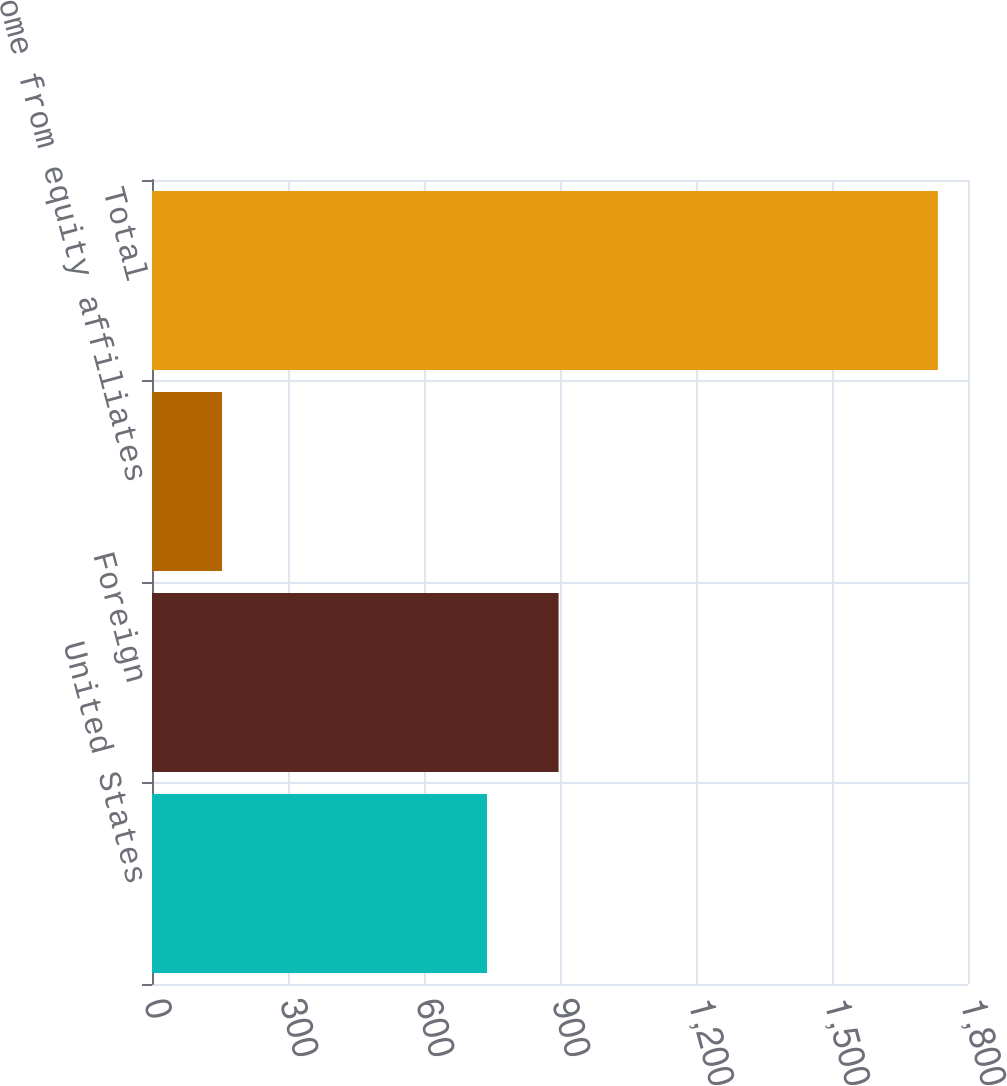Convert chart to OTSL. <chart><loc_0><loc_0><loc_500><loc_500><bar_chart><fcel>United States<fcel>Foreign<fcel>Income from equity affiliates<fcel>Total<nl><fcel>739<fcel>896.9<fcel>154.5<fcel>1733.5<nl></chart> 